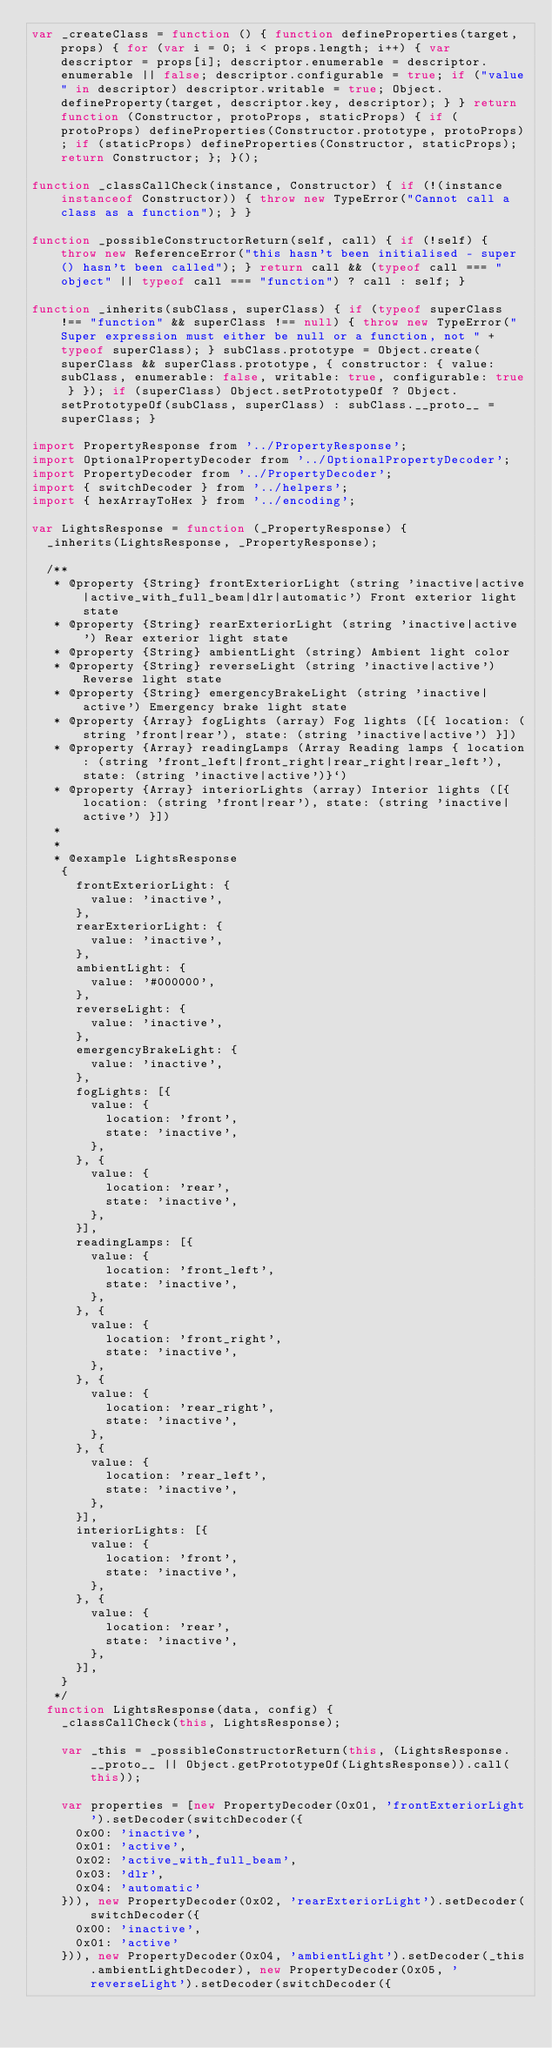Convert code to text. <code><loc_0><loc_0><loc_500><loc_500><_JavaScript_>var _createClass = function () { function defineProperties(target, props) { for (var i = 0; i < props.length; i++) { var descriptor = props[i]; descriptor.enumerable = descriptor.enumerable || false; descriptor.configurable = true; if ("value" in descriptor) descriptor.writable = true; Object.defineProperty(target, descriptor.key, descriptor); } } return function (Constructor, protoProps, staticProps) { if (protoProps) defineProperties(Constructor.prototype, protoProps); if (staticProps) defineProperties(Constructor, staticProps); return Constructor; }; }();

function _classCallCheck(instance, Constructor) { if (!(instance instanceof Constructor)) { throw new TypeError("Cannot call a class as a function"); } }

function _possibleConstructorReturn(self, call) { if (!self) { throw new ReferenceError("this hasn't been initialised - super() hasn't been called"); } return call && (typeof call === "object" || typeof call === "function") ? call : self; }

function _inherits(subClass, superClass) { if (typeof superClass !== "function" && superClass !== null) { throw new TypeError("Super expression must either be null or a function, not " + typeof superClass); } subClass.prototype = Object.create(superClass && superClass.prototype, { constructor: { value: subClass, enumerable: false, writable: true, configurable: true } }); if (superClass) Object.setPrototypeOf ? Object.setPrototypeOf(subClass, superClass) : subClass.__proto__ = superClass; }

import PropertyResponse from '../PropertyResponse';
import OptionalPropertyDecoder from '../OptionalPropertyDecoder';
import PropertyDecoder from '../PropertyDecoder';
import { switchDecoder } from '../helpers';
import { hexArrayToHex } from '../encoding';

var LightsResponse = function (_PropertyResponse) {
  _inherits(LightsResponse, _PropertyResponse);

  /**
   * @property {String} frontExteriorLight (string 'inactive|active|active_with_full_beam|dlr|automatic') Front exterior light state
   * @property {String} rearExteriorLight (string 'inactive|active') Rear exterior light state
   * @property {String} ambientLight (string) Ambient light color
   * @property {String} reverseLight (string 'inactive|active') Reverse light state
   * @property {String} emergencyBrakeLight (string 'inactive|active') Emergency brake light state
   * @property {Array} fogLights (array) Fog lights ([{ location: (string 'front|rear'), state: (string 'inactive|active') }])
   * @property {Array} readingLamps (Array Reading lamps { location: (string 'front_left|front_right|rear_right|rear_left'), state: (string 'inactive|active')}`)
   * @property {Array} interiorLights (array) Interior lights ([{ location: (string 'front|rear'), state: (string 'inactive|active') }])
   *
   *
   * @example LightsResponse
    {
      frontExteriorLight: {
        value: 'inactive',
      },
      rearExteriorLight: {
        value: 'inactive',
      },
      ambientLight: {
        value: '#000000',
      },
      reverseLight: {
        value: 'inactive',
      },
      emergencyBrakeLight: {
        value: 'inactive',
      },
      fogLights: [{
        value: {
          location: 'front',
          state: 'inactive',
        },
      }, {
        value: {
          location: 'rear',
          state: 'inactive',
        },
      }],
      readingLamps: [{
        value: {
          location: 'front_left',
          state: 'inactive',
        },
      }, {
        value: {
          location: 'front_right',
          state: 'inactive',
        },
      }, {
        value: {
          location: 'rear_right',
          state: 'inactive',
        },
      }, {
        value: {
          location: 'rear_left',
          state: 'inactive',
        },
      }],
      interiorLights: [{
        value: {
          location: 'front',
          state: 'inactive',
        },
      }, {
        value: {
          location: 'rear',
          state: 'inactive',
        },
      }],
    }
   */
  function LightsResponse(data, config) {
    _classCallCheck(this, LightsResponse);

    var _this = _possibleConstructorReturn(this, (LightsResponse.__proto__ || Object.getPrototypeOf(LightsResponse)).call(this));

    var properties = [new PropertyDecoder(0x01, 'frontExteriorLight').setDecoder(switchDecoder({
      0x00: 'inactive',
      0x01: 'active',
      0x02: 'active_with_full_beam',
      0x03: 'dlr',
      0x04: 'automatic'
    })), new PropertyDecoder(0x02, 'rearExteriorLight').setDecoder(switchDecoder({
      0x00: 'inactive',
      0x01: 'active'
    })), new PropertyDecoder(0x04, 'ambientLight').setDecoder(_this.ambientLightDecoder), new PropertyDecoder(0x05, 'reverseLight').setDecoder(switchDecoder({</code> 